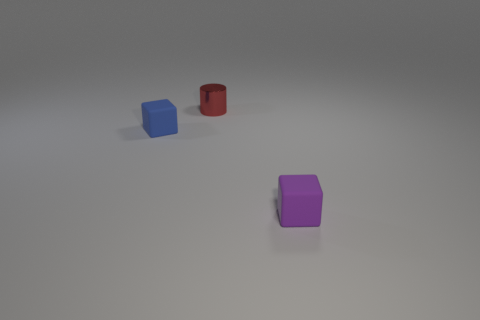Add 2 tiny purple blocks. How many objects exist? 5 Subtract all cylinders. How many objects are left? 2 Add 3 matte blocks. How many matte blocks exist? 5 Subtract 0 blue spheres. How many objects are left? 3 Subtract all tiny cubes. Subtract all red things. How many objects are left? 0 Add 1 blue things. How many blue things are left? 2 